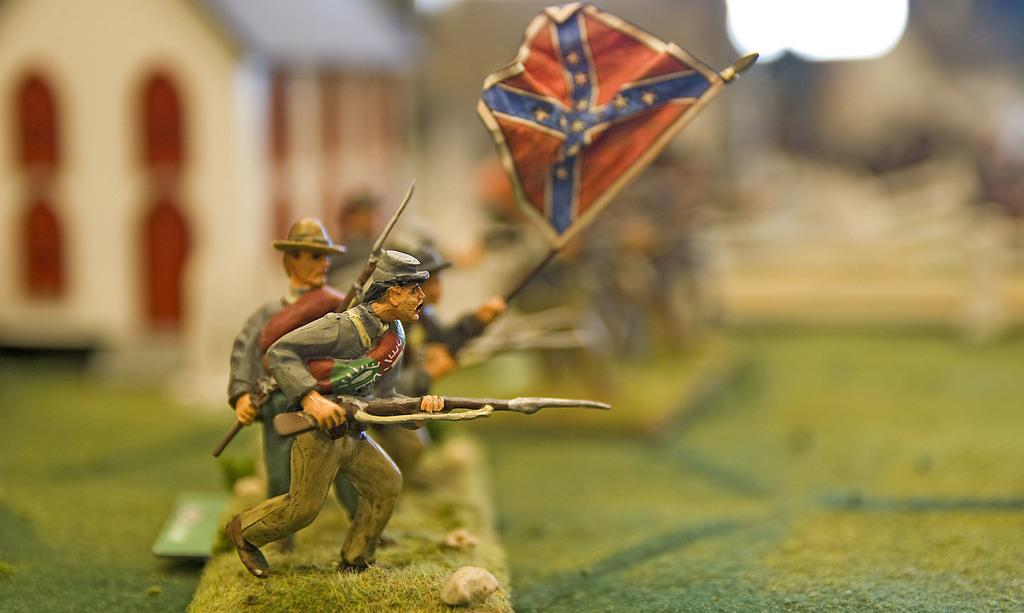What type of objects are depicted in the image? There are toys of people in the image. Can you describe the background of the image? The background of the image is blurred. What type of cream is being used to clean the chair in the image? There is no chair or cream present in the image; it features toys of people with a blurred background. What type of coach is visible in the image? There is no coach present in the image; it features toys of people with a blurred background. 